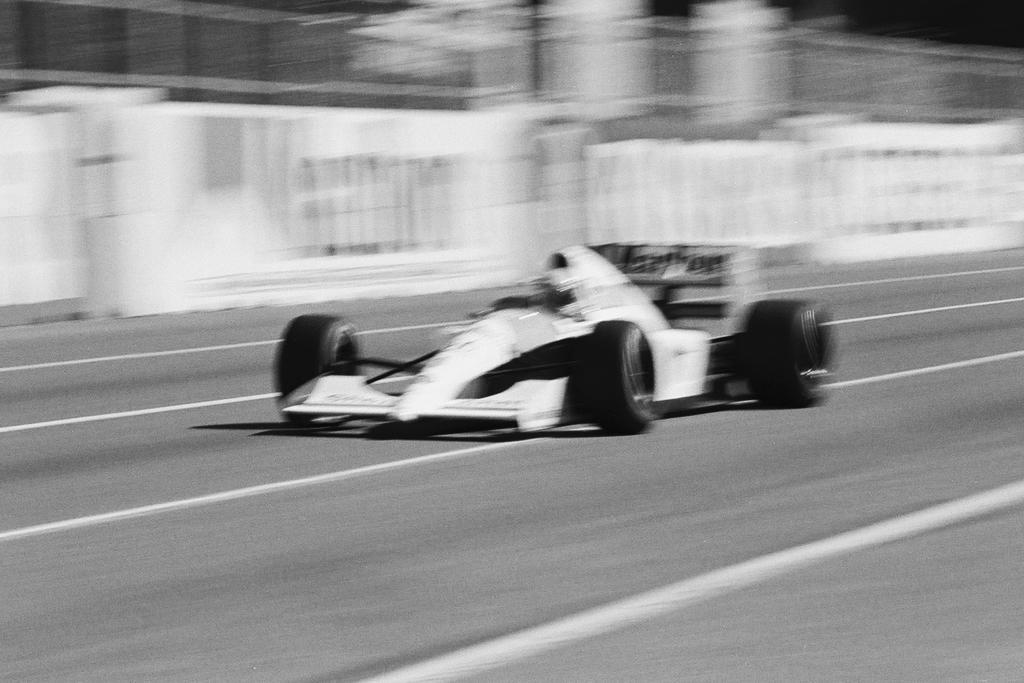Can you describe this image briefly? This is black and white image where we can see sport car on the road. Background of the image, banners are there. 